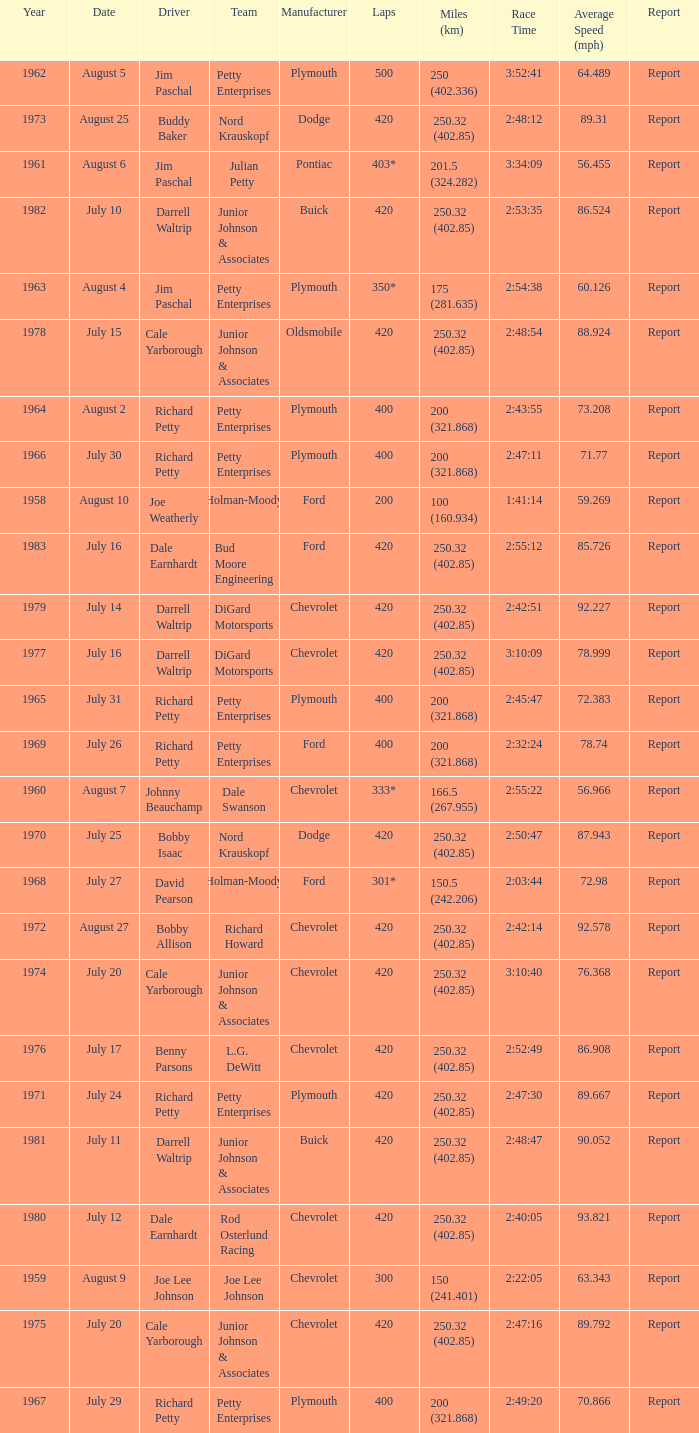How many miles were driven in the race where the winner finished in 2:47:11? 200 (321.868). 